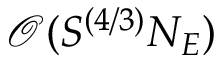Convert formula to latex. <formula><loc_0><loc_0><loc_500><loc_500>\mathcal { O } ( S ^ { ( 4 / 3 ) } N _ { E } )</formula> 